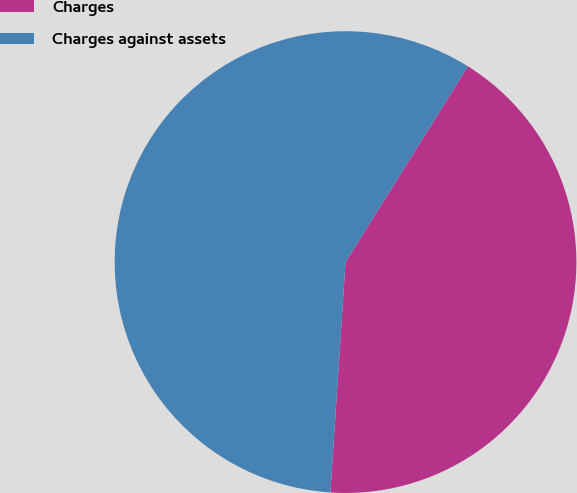Convert chart to OTSL. <chart><loc_0><loc_0><loc_500><loc_500><pie_chart><fcel>Charges<fcel>Charges against assets<nl><fcel>42.15%<fcel>57.85%<nl></chart> 